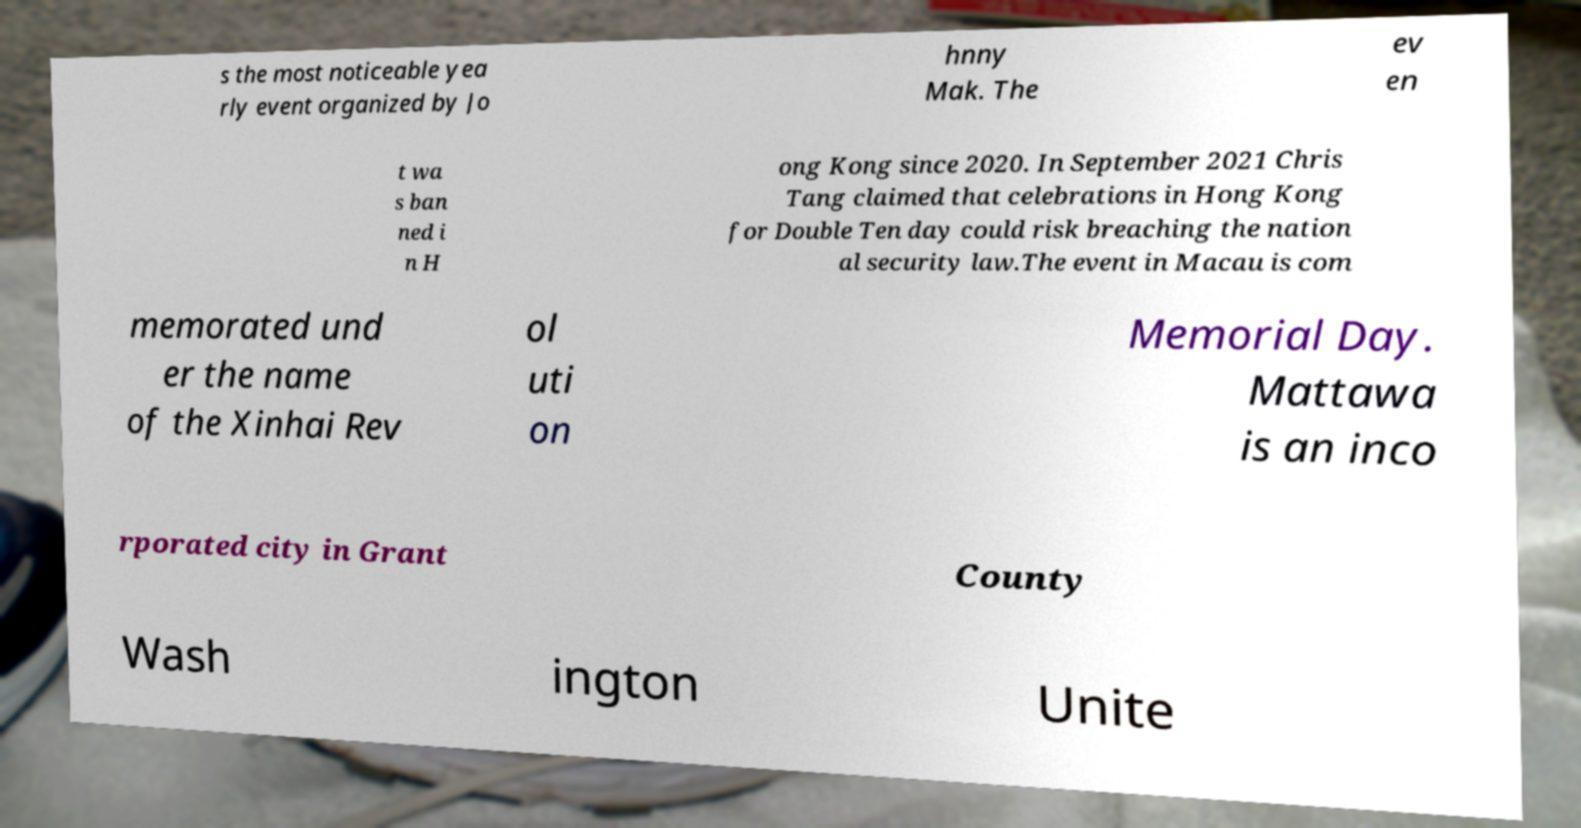Can you accurately transcribe the text from the provided image for me? s the most noticeable yea rly event organized by Jo hnny Mak. The ev en t wa s ban ned i n H ong Kong since 2020. In September 2021 Chris Tang claimed that celebrations in Hong Kong for Double Ten day could risk breaching the nation al security law.The event in Macau is com memorated und er the name of the Xinhai Rev ol uti on Memorial Day. Mattawa is an inco rporated city in Grant County Wash ington Unite 